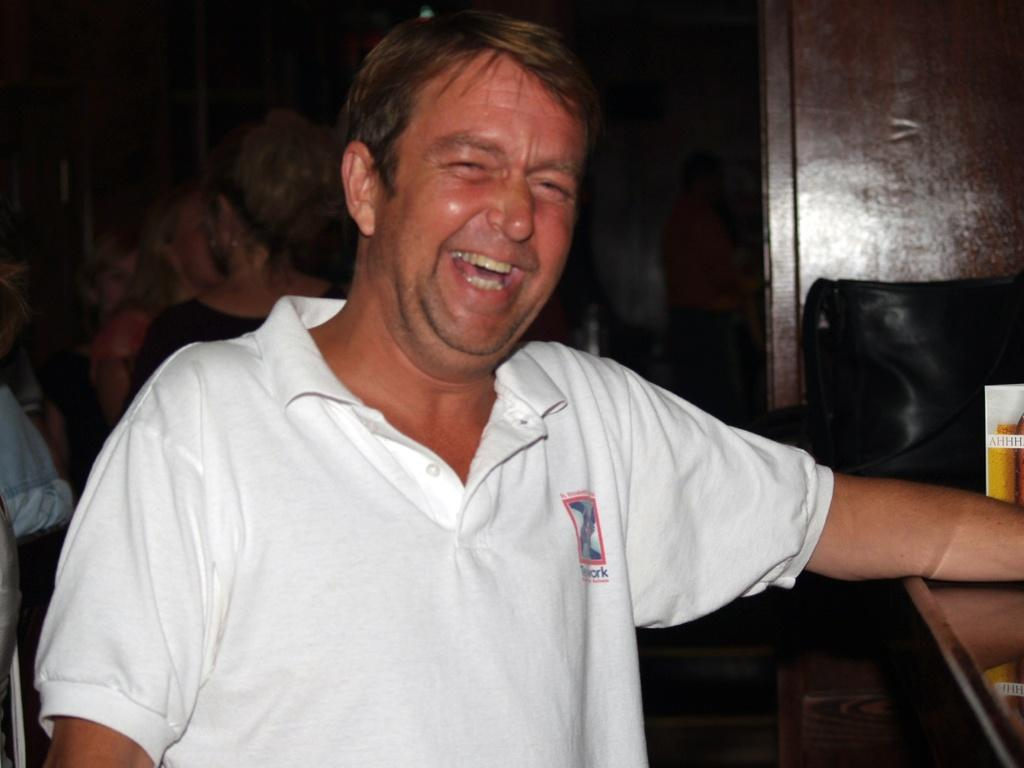Who is the main subject in the image? There is a man in the center of the image. What is the man doing in the image? The man is laughing. Can you describe the surroundings of the man? There are people in the background of the image. What item can be seen near the man? There is a bag visible in the image. What else is present in the image besides the man and the bag? There are other objects on a stand in the image. What type of tools does the carpenter have in the image? There is no carpenter present in the image, nor are there any tools visible. What kind of pets can be seen in the image? There are no pets visible in the image. 